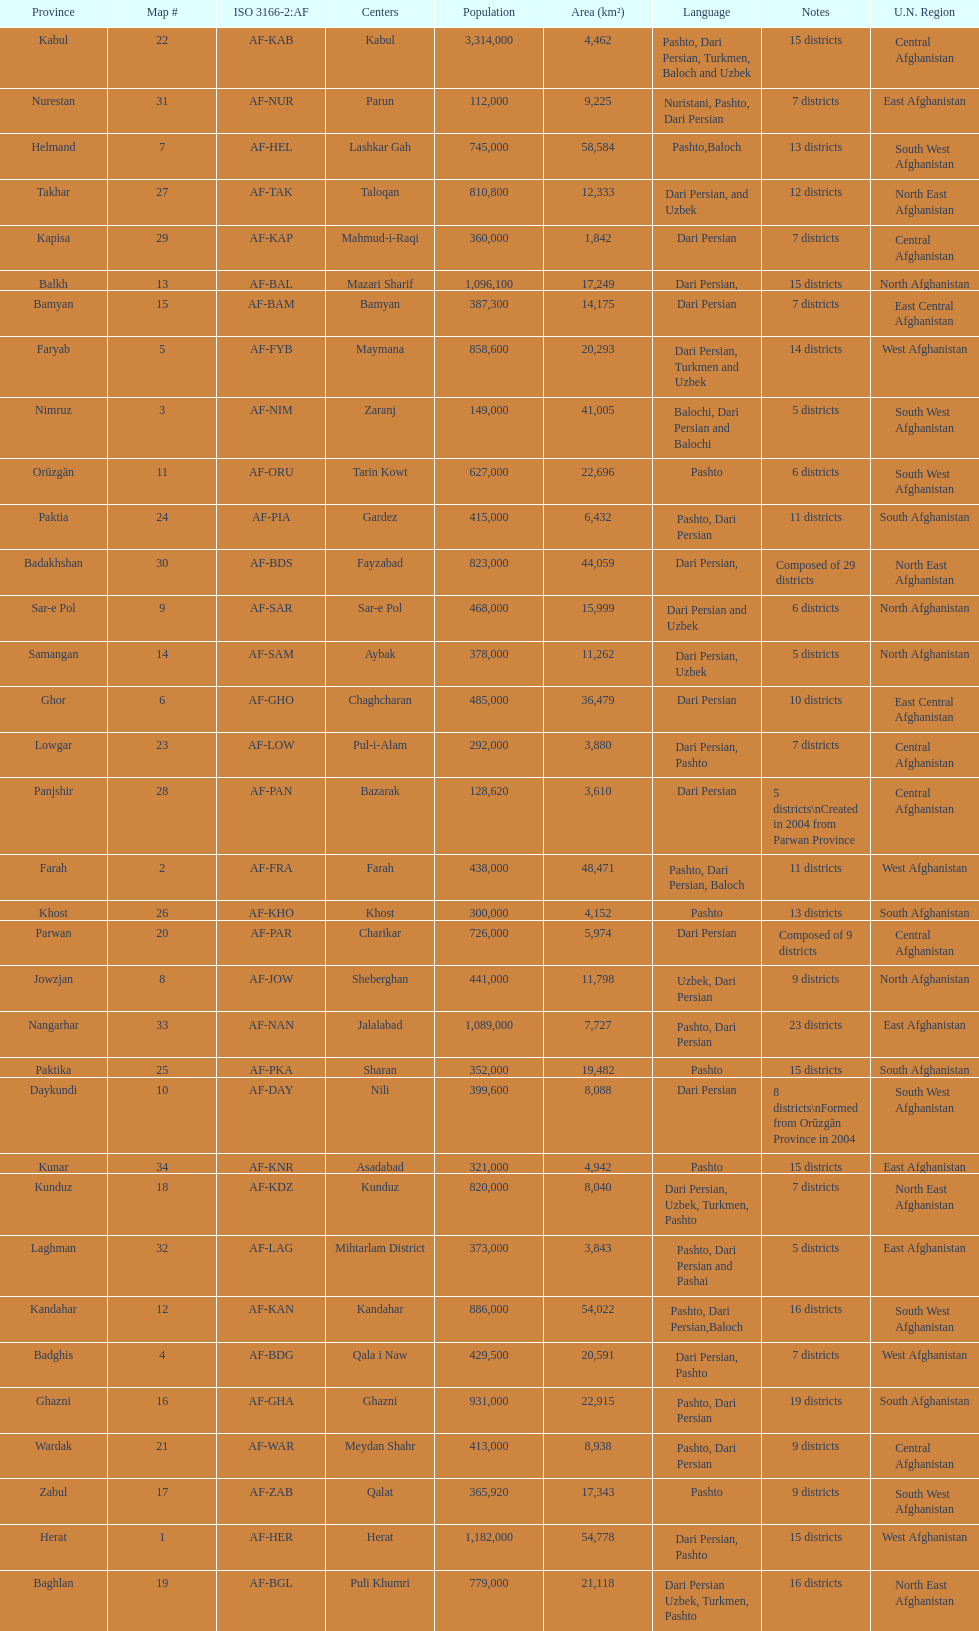How many provinces have pashto as one of their languages 20. 